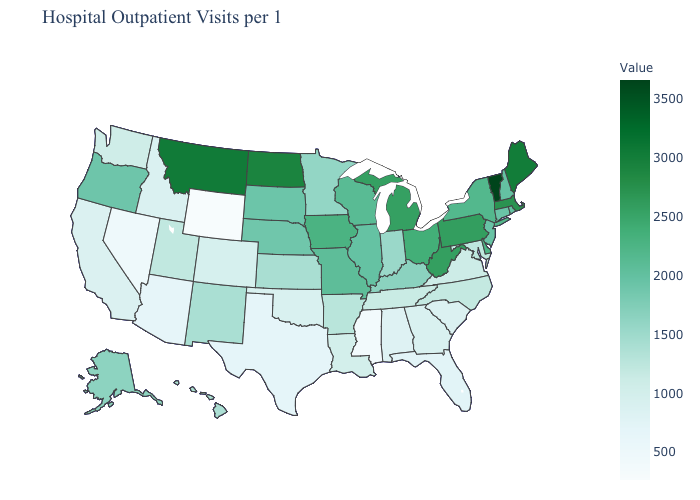Does the map have missing data?
Concise answer only. No. Which states have the highest value in the USA?
Keep it brief. Vermont. Which states have the lowest value in the Northeast?
Answer briefly. Connecticut. Does Wyoming have the lowest value in the USA?
Concise answer only. Yes. Among the states that border Arkansas , which have the highest value?
Answer briefly. Missouri. Which states have the lowest value in the Northeast?
Keep it brief. Connecticut. 